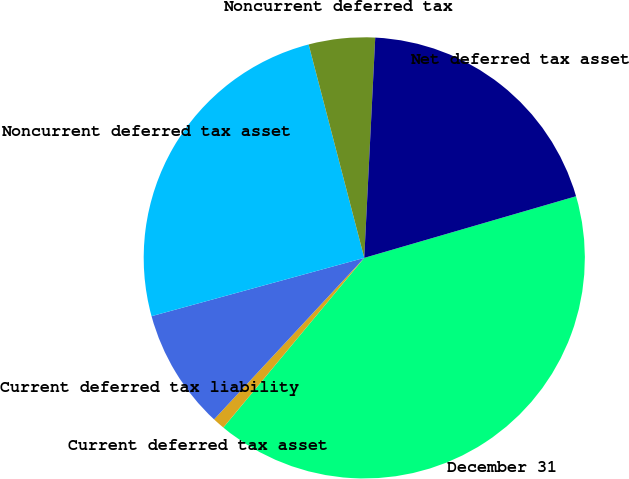Convert chart to OTSL. <chart><loc_0><loc_0><loc_500><loc_500><pie_chart><fcel>December 31<fcel>Current deferred tax asset<fcel>Current deferred tax liability<fcel>Noncurrent deferred tax asset<fcel>Noncurrent deferred tax<fcel>Net deferred tax asset<nl><fcel>40.54%<fcel>0.89%<fcel>8.82%<fcel>25.2%<fcel>4.85%<fcel>19.7%<nl></chart> 